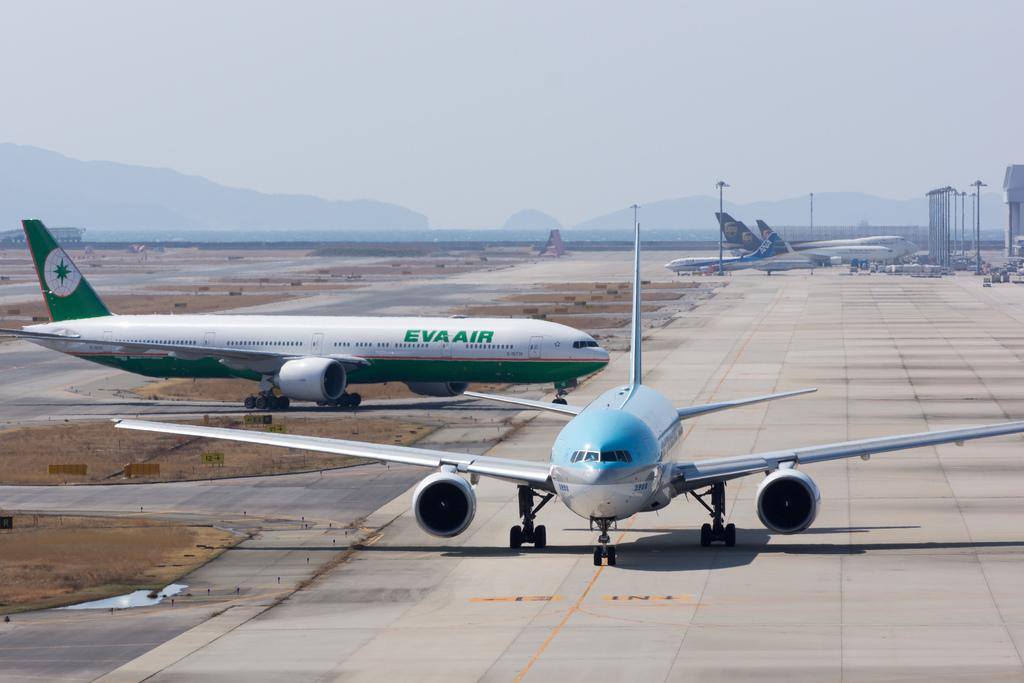<image>
Write a terse but informative summary of the picture. An airplane on a runway and another that says Eva Air 